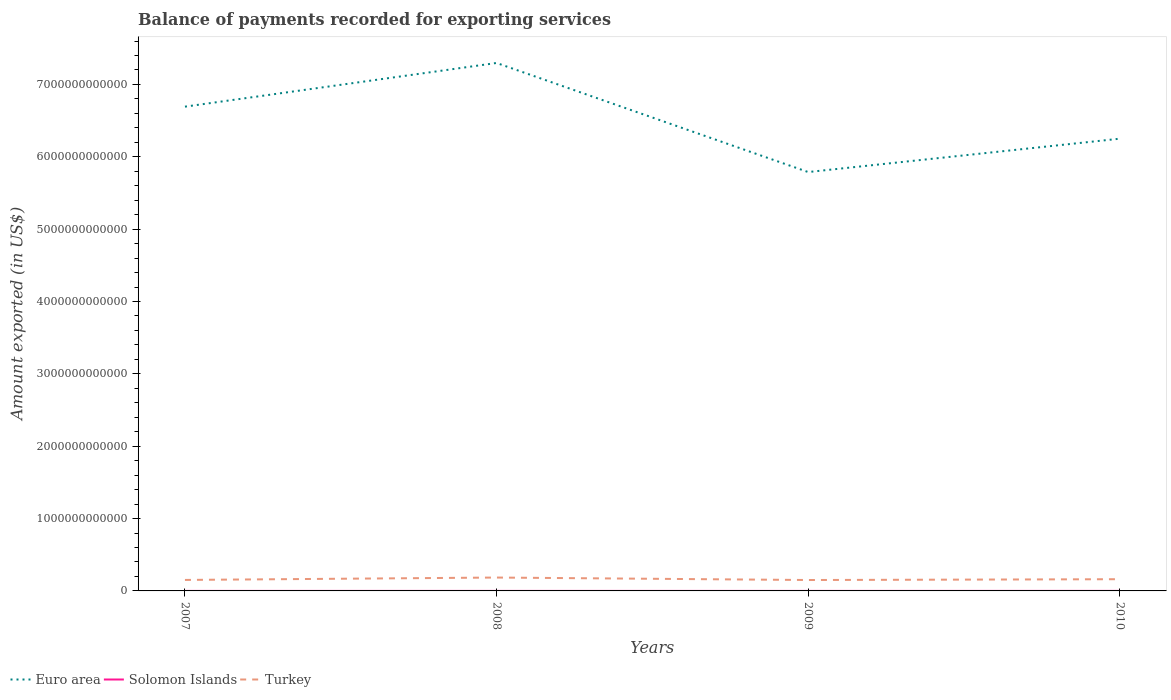Across all years, what is the maximum amount exported in Solomon Islands?
Make the answer very short. 2.33e+08. What is the total amount exported in Euro area in the graph?
Your answer should be very brief. 9.04e+11. What is the difference between the highest and the second highest amount exported in Solomon Islands?
Offer a terse response. 1.00e+08. Is the amount exported in Euro area strictly greater than the amount exported in Turkey over the years?
Keep it short and to the point. No. How many lines are there?
Give a very brief answer. 3. What is the difference between two consecutive major ticks on the Y-axis?
Keep it short and to the point. 1.00e+12. Does the graph contain any zero values?
Your answer should be compact. No. Does the graph contain grids?
Keep it short and to the point. No. Where does the legend appear in the graph?
Offer a terse response. Bottom left. What is the title of the graph?
Offer a terse response. Balance of payments recorded for exporting services. Does "Georgia" appear as one of the legend labels in the graph?
Your response must be concise. No. What is the label or title of the X-axis?
Your answer should be very brief. Years. What is the label or title of the Y-axis?
Your answer should be very brief. Amount exported (in US$). What is the Amount exported (in US$) of Euro area in 2007?
Your answer should be compact. 6.69e+12. What is the Amount exported (in US$) in Solomon Islands in 2007?
Keep it short and to the point. 2.33e+08. What is the Amount exported (in US$) of Turkey in 2007?
Provide a succinct answer. 1.52e+11. What is the Amount exported (in US$) of Euro area in 2008?
Your response must be concise. 7.30e+12. What is the Amount exported (in US$) in Solomon Islands in 2008?
Keep it short and to the point. 2.80e+08. What is the Amount exported (in US$) of Turkey in 2008?
Make the answer very short. 1.85e+11. What is the Amount exported (in US$) in Euro area in 2009?
Provide a short and direct response. 5.79e+12. What is the Amount exported (in US$) of Solomon Islands in 2009?
Your answer should be compact. 2.37e+08. What is the Amount exported (in US$) of Turkey in 2009?
Provide a short and direct response. 1.51e+11. What is the Amount exported (in US$) in Euro area in 2010?
Provide a short and direct response. 6.25e+12. What is the Amount exported (in US$) in Solomon Islands in 2010?
Your answer should be very brief. 3.33e+08. What is the Amount exported (in US$) in Turkey in 2010?
Make the answer very short. 1.62e+11. Across all years, what is the maximum Amount exported (in US$) of Euro area?
Ensure brevity in your answer.  7.30e+12. Across all years, what is the maximum Amount exported (in US$) in Solomon Islands?
Keep it short and to the point. 3.33e+08. Across all years, what is the maximum Amount exported (in US$) in Turkey?
Your answer should be very brief. 1.85e+11. Across all years, what is the minimum Amount exported (in US$) of Euro area?
Your answer should be compact. 5.79e+12. Across all years, what is the minimum Amount exported (in US$) in Solomon Islands?
Give a very brief answer. 2.33e+08. Across all years, what is the minimum Amount exported (in US$) in Turkey?
Your response must be concise. 1.51e+11. What is the total Amount exported (in US$) of Euro area in the graph?
Your answer should be very brief. 2.60e+13. What is the total Amount exported (in US$) of Solomon Islands in the graph?
Your answer should be compact. 1.08e+09. What is the total Amount exported (in US$) of Turkey in the graph?
Provide a short and direct response. 6.49e+11. What is the difference between the Amount exported (in US$) of Euro area in 2007 and that in 2008?
Offer a terse response. -6.04e+11. What is the difference between the Amount exported (in US$) in Solomon Islands in 2007 and that in 2008?
Provide a short and direct response. -4.70e+07. What is the difference between the Amount exported (in US$) of Turkey in 2007 and that in 2008?
Your answer should be compact. -3.31e+1. What is the difference between the Amount exported (in US$) in Euro area in 2007 and that in 2009?
Your answer should be very brief. 9.04e+11. What is the difference between the Amount exported (in US$) in Solomon Islands in 2007 and that in 2009?
Provide a succinct answer. -4.52e+06. What is the difference between the Amount exported (in US$) of Turkey in 2007 and that in 2009?
Your response must be concise. 1.10e+09. What is the difference between the Amount exported (in US$) in Euro area in 2007 and that in 2010?
Your answer should be very brief. 4.43e+11. What is the difference between the Amount exported (in US$) of Solomon Islands in 2007 and that in 2010?
Keep it short and to the point. -1.00e+08. What is the difference between the Amount exported (in US$) in Turkey in 2007 and that in 2010?
Make the answer very short. -1.01e+1. What is the difference between the Amount exported (in US$) in Euro area in 2008 and that in 2009?
Your response must be concise. 1.51e+12. What is the difference between the Amount exported (in US$) of Solomon Islands in 2008 and that in 2009?
Your answer should be very brief. 4.25e+07. What is the difference between the Amount exported (in US$) in Turkey in 2008 and that in 2009?
Provide a short and direct response. 3.42e+1. What is the difference between the Amount exported (in US$) in Euro area in 2008 and that in 2010?
Your answer should be compact. 1.05e+12. What is the difference between the Amount exported (in US$) in Solomon Islands in 2008 and that in 2010?
Keep it short and to the point. -5.34e+07. What is the difference between the Amount exported (in US$) in Turkey in 2008 and that in 2010?
Make the answer very short. 2.30e+1. What is the difference between the Amount exported (in US$) of Euro area in 2009 and that in 2010?
Give a very brief answer. -4.61e+11. What is the difference between the Amount exported (in US$) in Solomon Islands in 2009 and that in 2010?
Provide a succinct answer. -9.59e+07. What is the difference between the Amount exported (in US$) in Turkey in 2009 and that in 2010?
Offer a very short reply. -1.12e+1. What is the difference between the Amount exported (in US$) in Euro area in 2007 and the Amount exported (in US$) in Solomon Islands in 2008?
Your response must be concise. 6.69e+12. What is the difference between the Amount exported (in US$) of Euro area in 2007 and the Amount exported (in US$) of Turkey in 2008?
Offer a very short reply. 6.51e+12. What is the difference between the Amount exported (in US$) of Solomon Islands in 2007 and the Amount exported (in US$) of Turkey in 2008?
Give a very brief answer. -1.85e+11. What is the difference between the Amount exported (in US$) of Euro area in 2007 and the Amount exported (in US$) of Solomon Islands in 2009?
Make the answer very short. 6.69e+12. What is the difference between the Amount exported (in US$) of Euro area in 2007 and the Amount exported (in US$) of Turkey in 2009?
Ensure brevity in your answer.  6.54e+12. What is the difference between the Amount exported (in US$) in Solomon Islands in 2007 and the Amount exported (in US$) in Turkey in 2009?
Keep it short and to the point. -1.50e+11. What is the difference between the Amount exported (in US$) of Euro area in 2007 and the Amount exported (in US$) of Solomon Islands in 2010?
Your answer should be very brief. 6.69e+12. What is the difference between the Amount exported (in US$) in Euro area in 2007 and the Amount exported (in US$) in Turkey in 2010?
Offer a very short reply. 6.53e+12. What is the difference between the Amount exported (in US$) of Solomon Islands in 2007 and the Amount exported (in US$) of Turkey in 2010?
Give a very brief answer. -1.62e+11. What is the difference between the Amount exported (in US$) in Euro area in 2008 and the Amount exported (in US$) in Solomon Islands in 2009?
Your response must be concise. 7.30e+12. What is the difference between the Amount exported (in US$) in Euro area in 2008 and the Amount exported (in US$) in Turkey in 2009?
Make the answer very short. 7.15e+12. What is the difference between the Amount exported (in US$) of Solomon Islands in 2008 and the Amount exported (in US$) of Turkey in 2009?
Offer a very short reply. -1.50e+11. What is the difference between the Amount exported (in US$) of Euro area in 2008 and the Amount exported (in US$) of Solomon Islands in 2010?
Provide a succinct answer. 7.30e+12. What is the difference between the Amount exported (in US$) of Euro area in 2008 and the Amount exported (in US$) of Turkey in 2010?
Keep it short and to the point. 7.13e+12. What is the difference between the Amount exported (in US$) of Solomon Islands in 2008 and the Amount exported (in US$) of Turkey in 2010?
Give a very brief answer. -1.62e+11. What is the difference between the Amount exported (in US$) in Euro area in 2009 and the Amount exported (in US$) in Solomon Islands in 2010?
Provide a succinct answer. 5.79e+12. What is the difference between the Amount exported (in US$) in Euro area in 2009 and the Amount exported (in US$) in Turkey in 2010?
Make the answer very short. 5.63e+12. What is the difference between the Amount exported (in US$) of Solomon Islands in 2009 and the Amount exported (in US$) of Turkey in 2010?
Keep it short and to the point. -1.62e+11. What is the average Amount exported (in US$) in Euro area per year?
Provide a short and direct response. 6.51e+12. What is the average Amount exported (in US$) of Solomon Islands per year?
Give a very brief answer. 2.71e+08. What is the average Amount exported (in US$) of Turkey per year?
Your answer should be compact. 1.62e+11. In the year 2007, what is the difference between the Amount exported (in US$) of Euro area and Amount exported (in US$) of Solomon Islands?
Provide a short and direct response. 6.69e+12. In the year 2007, what is the difference between the Amount exported (in US$) of Euro area and Amount exported (in US$) of Turkey?
Keep it short and to the point. 6.54e+12. In the year 2007, what is the difference between the Amount exported (in US$) in Solomon Islands and Amount exported (in US$) in Turkey?
Your response must be concise. -1.52e+11. In the year 2008, what is the difference between the Amount exported (in US$) of Euro area and Amount exported (in US$) of Solomon Islands?
Provide a short and direct response. 7.30e+12. In the year 2008, what is the difference between the Amount exported (in US$) in Euro area and Amount exported (in US$) in Turkey?
Your answer should be compact. 7.11e+12. In the year 2008, what is the difference between the Amount exported (in US$) in Solomon Islands and Amount exported (in US$) in Turkey?
Your answer should be very brief. -1.85e+11. In the year 2009, what is the difference between the Amount exported (in US$) in Euro area and Amount exported (in US$) in Solomon Islands?
Offer a terse response. 5.79e+12. In the year 2009, what is the difference between the Amount exported (in US$) of Euro area and Amount exported (in US$) of Turkey?
Your response must be concise. 5.64e+12. In the year 2009, what is the difference between the Amount exported (in US$) of Solomon Islands and Amount exported (in US$) of Turkey?
Ensure brevity in your answer.  -1.50e+11. In the year 2010, what is the difference between the Amount exported (in US$) in Euro area and Amount exported (in US$) in Solomon Islands?
Keep it short and to the point. 6.25e+12. In the year 2010, what is the difference between the Amount exported (in US$) of Euro area and Amount exported (in US$) of Turkey?
Your response must be concise. 6.09e+12. In the year 2010, what is the difference between the Amount exported (in US$) in Solomon Islands and Amount exported (in US$) in Turkey?
Give a very brief answer. -1.62e+11. What is the ratio of the Amount exported (in US$) of Euro area in 2007 to that in 2008?
Your response must be concise. 0.92. What is the ratio of the Amount exported (in US$) in Solomon Islands in 2007 to that in 2008?
Your response must be concise. 0.83. What is the ratio of the Amount exported (in US$) in Turkey in 2007 to that in 2008?
Provide a short and direct response. 0.82. What is the ratio of the Amount exported (in US$) in Euro area in 2007 to that in 2009?
Offer a very short reply. 1.16. What is the ratio of the Amount exported (in US$) of Turkey in 2007 to that in 2009?
Your response must be concise. 1.01. What is the ratio of the Amount exported (in US$) in Euro area in 2007 to that in 2010?
Ensure brevity in your answer.  1.07. What is the ratio of the Amount exported (in US$) of Solomon Islands in 2007 to that in 2010?
Keep it short and to the point. 0.7. What is the ratio of the Amount exported (in US$) in Euro area in 2008 to that in 2009?
Offer a terse response. 1.26. What is the ratio of the Amount exported (in US$) in Solomon Islands in 2008 to that in 2009?
Offer a very short reply. 1.18. What is the ratio of the Amount exported (in US$) in Turkey in 2008 to that in 2009?
Ensure brevity in your answer.  1.23. What is the ratio of the Amount exported (in US$) of Euro area in 2008 to that in 2010?
Ensure brevity in your answer.  1.17. What is the ratio of the Amount exported (in US$) in Solomon Islands in 2008 to that in 2010?
Ensure brevity in your answer.  0.84. What is the ratio of the Amount exported (in US$) of Turkey in 2008 to that in 2010?
Make the answer very short. 1.14. What is the ratio of the Amount exported (in US$) of Euro area in 2009 to that in 2010?
Give a very brief answer. 0.93. What is the ratio of the Amount exported (in US$) of Solomon Islands in 2009 to that in 2010?
Ensure brevity in your answer.  0.71. What is the ratio of the Amount exported (in US$) in Turkey in 2009 to that in 2010?
Give a very brief answer. 0.93. What is the difference between the highest and the second highest Amount exported (in US$) in Euro area?
Provide a succinct answer. 6.04e+11. What is the difference between the highest and the second highest Amount exported (in US$) of Solomon Islands?
Your answer should be very brief. 5.34e+07. What is the difference between the highest and the second highest Amount exported (in US$) of Turkey?
Give a very brief answer. 2.30e+1. What is the difference between the highest and the lowest Amount exported (in US$) in Euro area?
Your answer should be very brief. 1.51e+12. What is the difference between the highest and the lowest Amount exported (in US$) in Solomon Islands?
Keep it short and to the point. 1.00e+08. What is the difference between the highest and the lowest Amount exported (in US$) in Turkey?
Keep it short and to the point. 3.42e+1. 